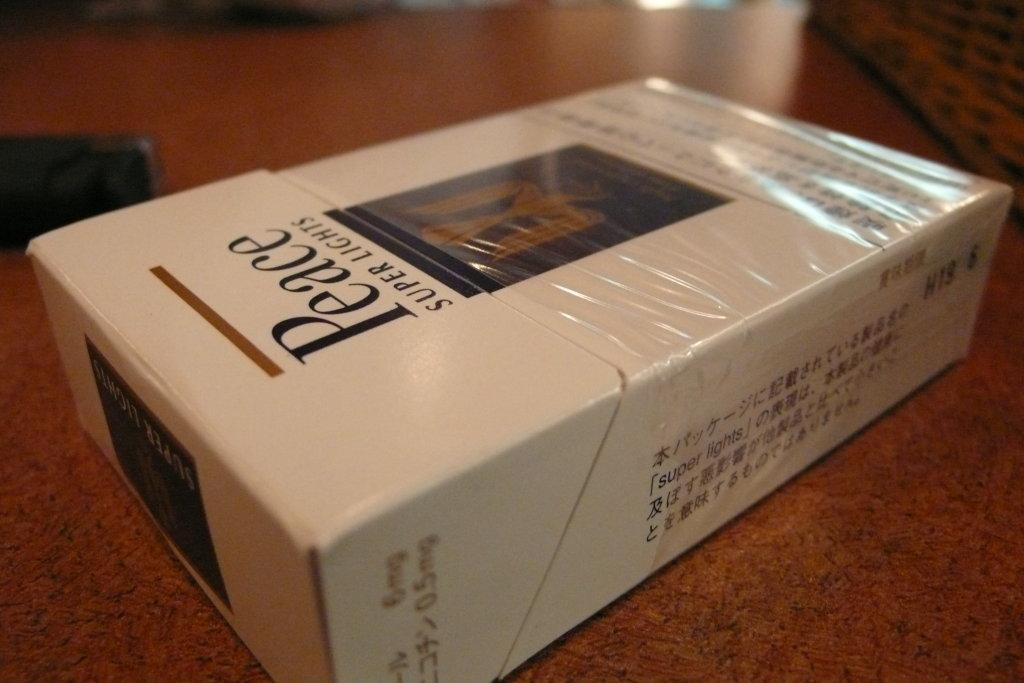<image>
Relay a brief, clear account of the picture shown. A box of Peace super lights is laying on a counter. 